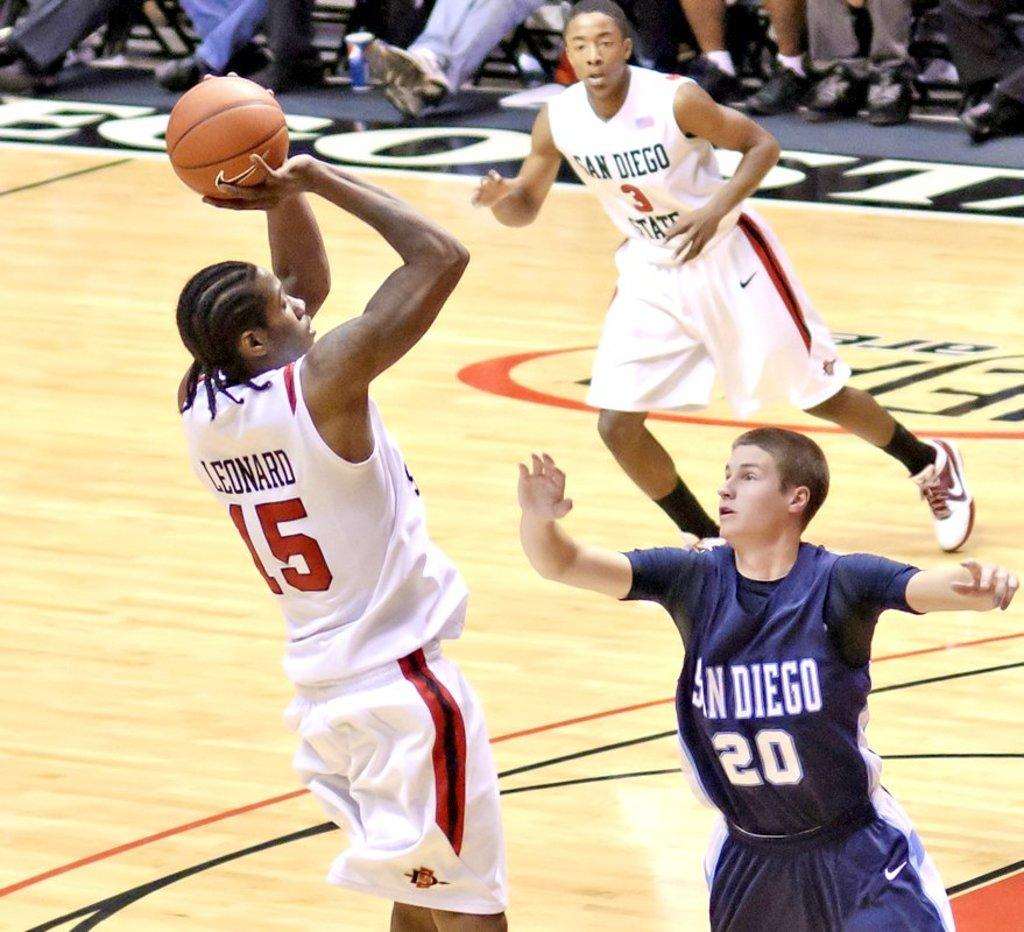What activity are the people engaged in within the image? The people are playing in the court. What object is being used in their game? There is a ball in the image. What type of surface are they playing on? There is a floor in the image. Can you describe the lower part of the people in the image? Human legs with shoes are visible at the top of the image. How many potatoes can be seen in the image? There are no potatoes present in the image. What type of grain is being harvested in the image? There is no grain or harvesting activity depicted in the image. 